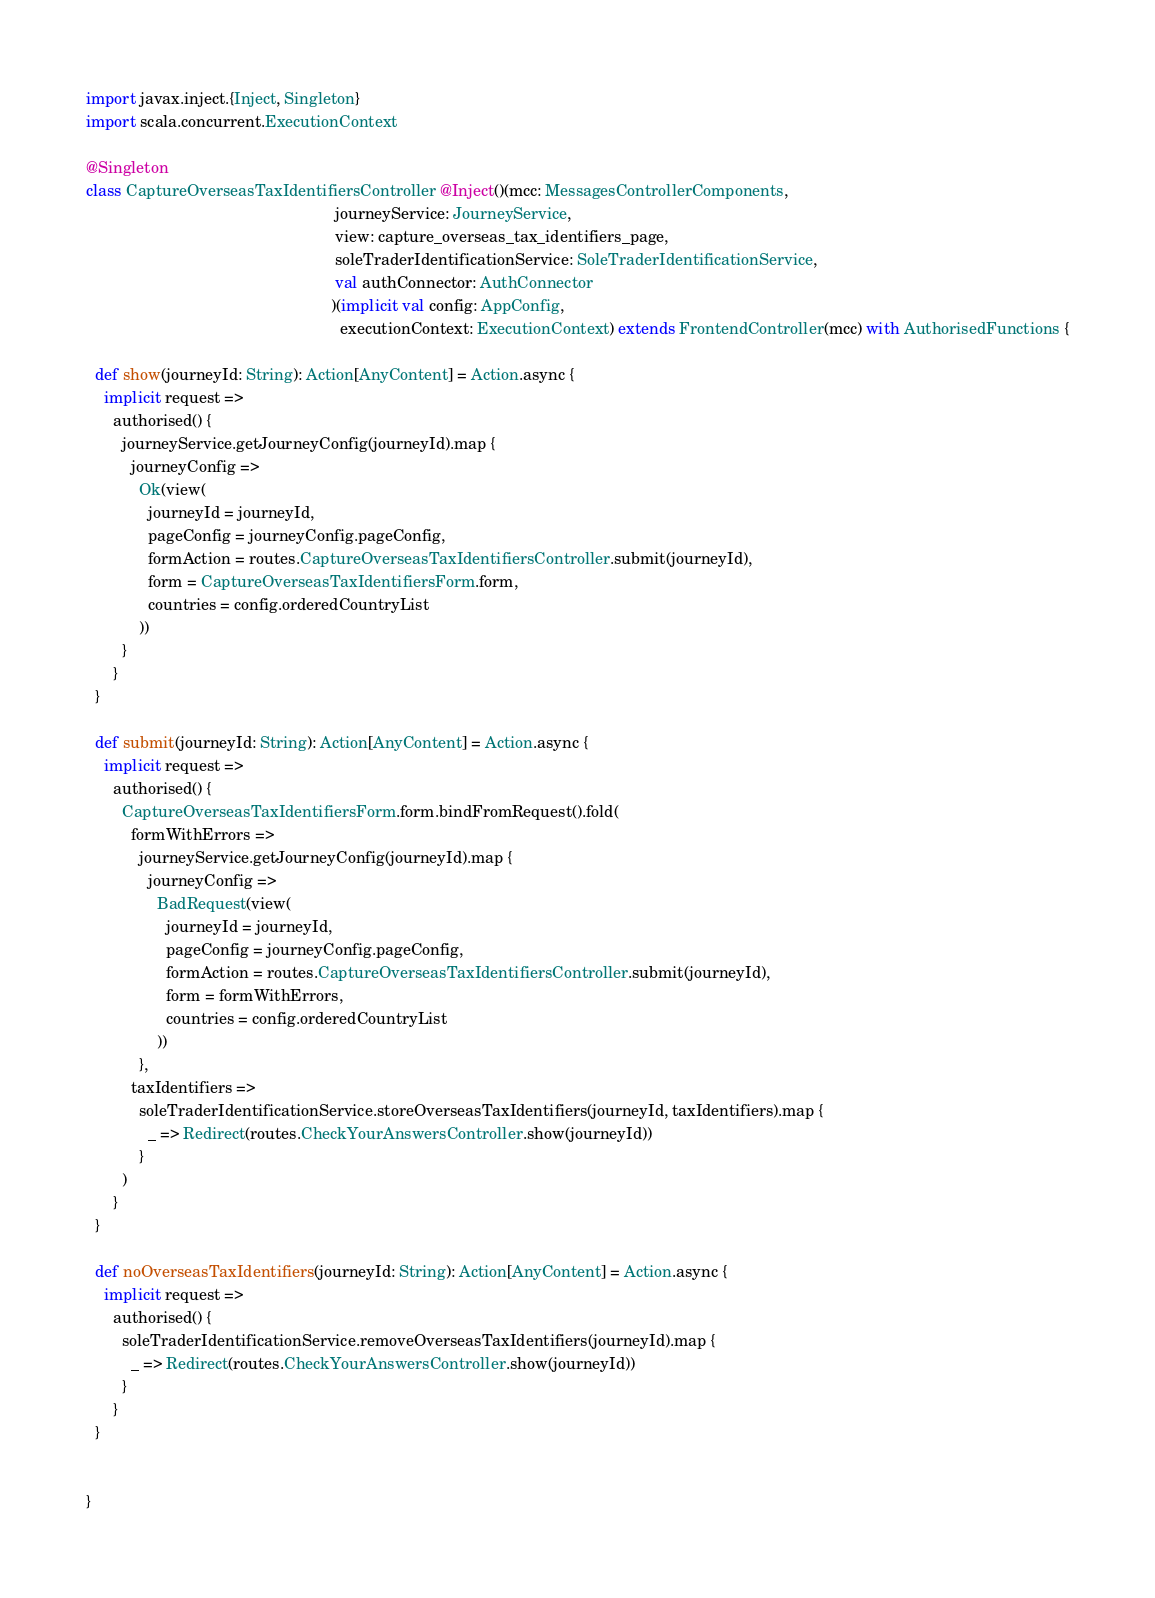<code> <loc_0><loc_0><loc_500><loc_500><_Scala_>import javax.inject.{Inject, Singleton}
import scala.concurrent.ExecutionContext

@Singleton
class CaptureOverseasTaxIdentifiersController @Inject()(mcc: MessagesControllerComponents,
                                                        journeyService: JourneyService,
                                                        view: capture_overseas_tax_identifiers_page,
                                                        soleTraderIdentificationService: SoleTraderIdentificationService,
                                                        val authConnector: AuthConnector
                                                       )(implicit val config: AppConfig,
                                                         executionContext: ExecutionContext) extends FrontendController(mcc) with AuthorisedFunctions {

  def show(journeyId: String): Action[AnyContent] = Action.async {
    implicit request =>
      authorised() {
        journeyService.getJourneyConfig(journeyId).map {
          journeyConfig =>
            Ok(view(
              journeyId = journeyId,
              pageConfig = journeyConfig.pageConfig,
              formAction = routes.CaptureOverseasTaxIdentifiersController.submit(journeyId),
              form = CaptureOverseasTaxIdentifiersForm.form,
              countries = config.orderedCountryList
            ))
        }
      }
  }

  def submit(journeyId: String): Action[AnyContent] = Action.async {
    implicit request =>
      authorised() {
        CaptureOverseasTaxIdentifiersForm.form.bindFromRequest().fold(
          formWithErrors =>
            journeyService.getJourneyConfig(journeyId).map {
              journeyConfig =>
                BadRequest(view(
                  journeyId = journeyId,
                  pageConfig = journeyConfig.pageConfig,
                  formAction = routes.CaptureOverseasTaxIdentifiersController.submit(journeyId),
                  form = formWithErrors,
                  countries = config.orderedCountryList
                ))
            },
          taxIdentifiers =>
            soleTraderIdentificationService.storeOverseasTaxIdentifiers(journeyId, taxIdentifiers).map {
              _ => Redirect(routes.CheckYourAnswersController.show(journeyId))
            }
        )
      }
  }

  def noOverseasTaxIdentifiers(journeyId: String): Action[AnyContent] = Action.async {
    implicit request =>
      authorised() {
        soleTraderIdentificationService.removeOverseasTaxIdentifiers(journeyId).map {
          _ => Redirect(routes.CheckYourAnswersController.show(journeyId))
        }
      }
  }


}
</code> 